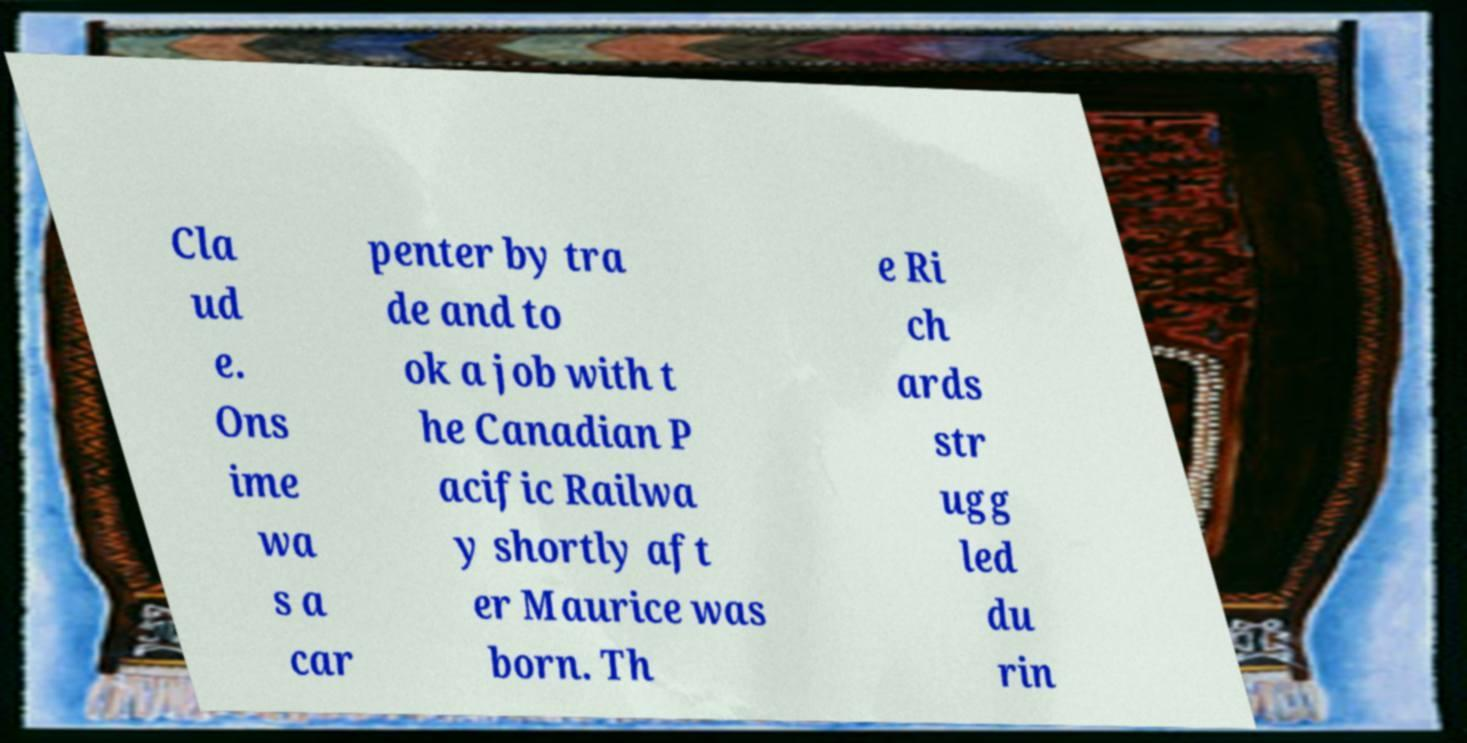Can you accurately transcribe the text from the provided image for me? Cla ud e. Ons ime wa s a car penter by tra de and to ok a job with t he Canadian P acific Railwa y shortly aft er Maurice was born. Th e Ri ch ards str ugg led du rin 